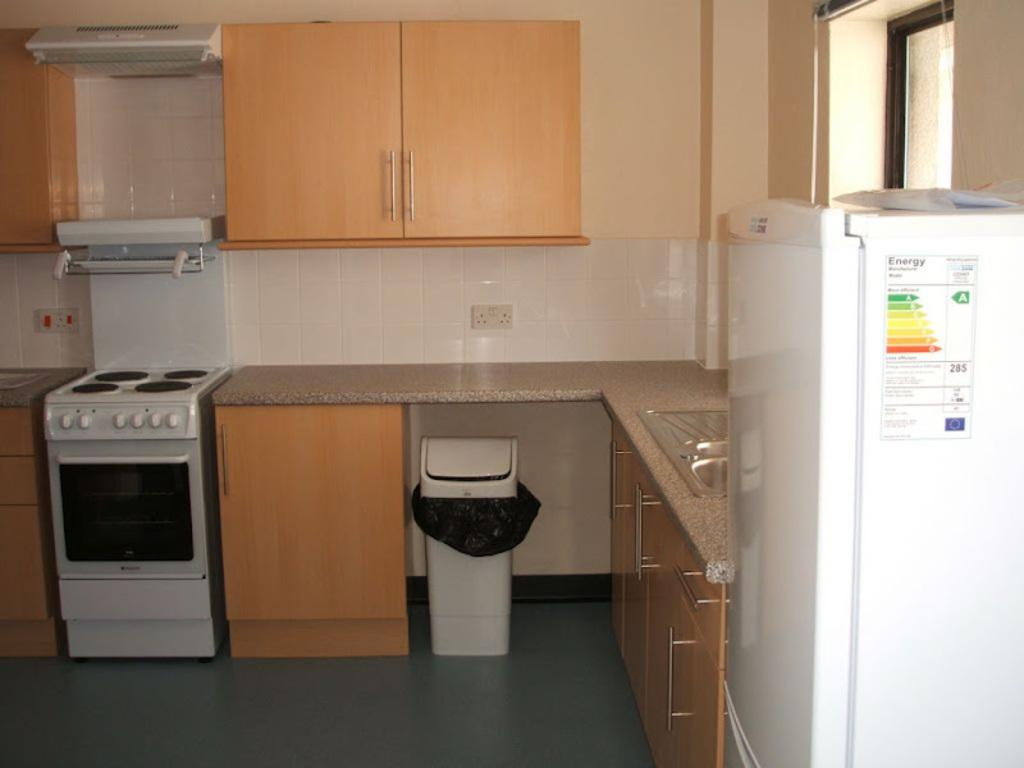<image>
Offer a succinct explanation of the picture presented. A clean kitchen with the word energy on the side of the fridge 